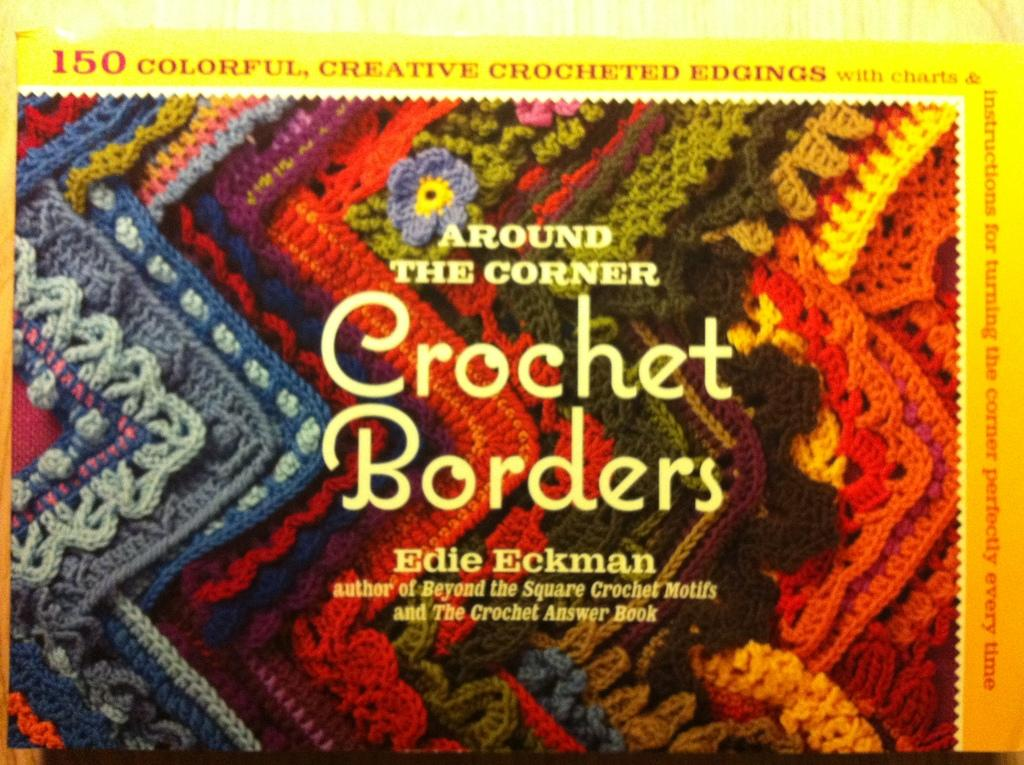<image>
Give a short and clear explanation of the subsequent image. a crochet borders advertisement that is in yellow text 